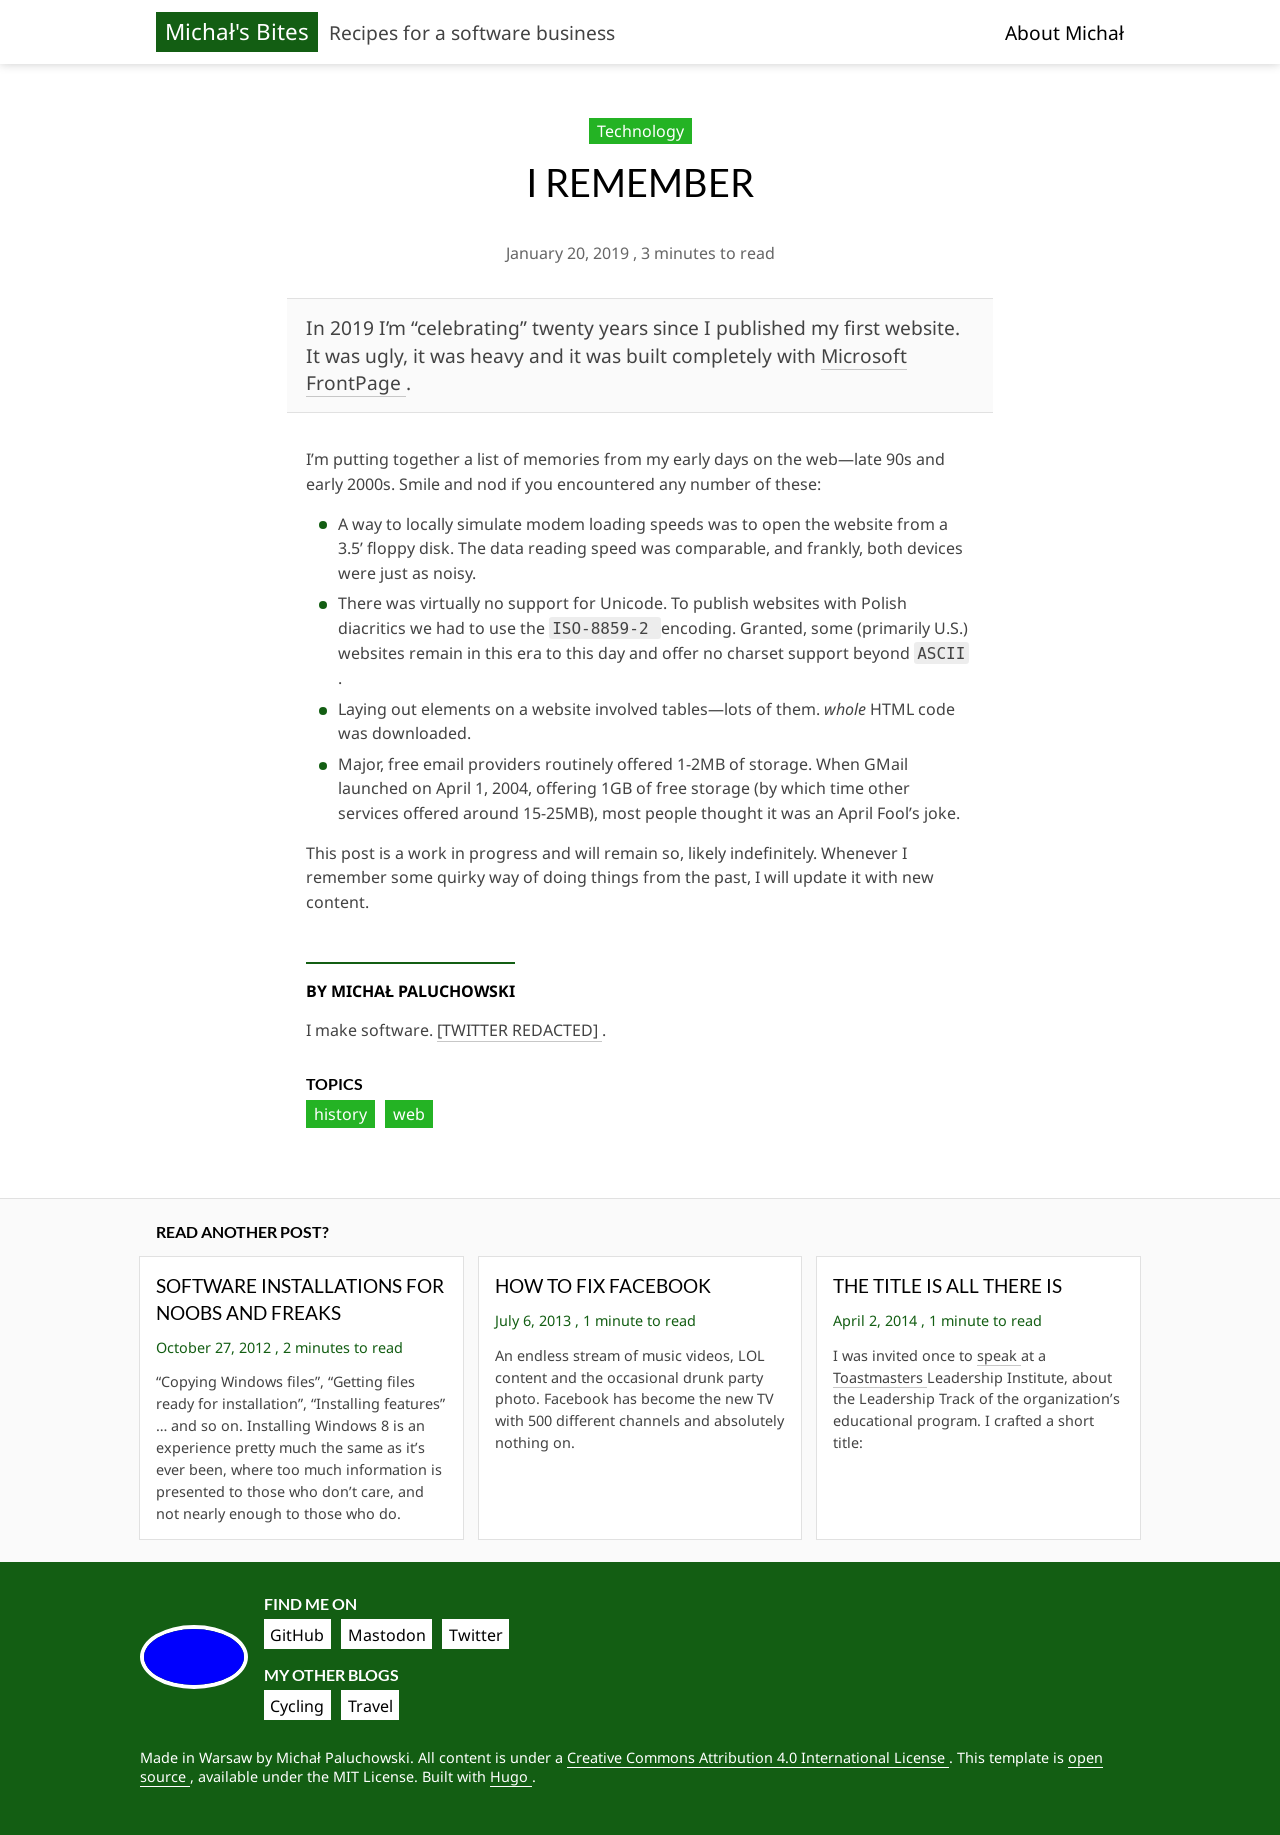What are some design elements shown on this webpage that you think make it user-friendly? The design of the webpage displays a clear, structured layout with well-organized sections, making navigation straightforward. The usage of headings and subheadings helps in distinguishing different parts of the content, enhancing readability. Furthermore, the limited color palette and consistent font styles contribute to a cohesive and professional look. 